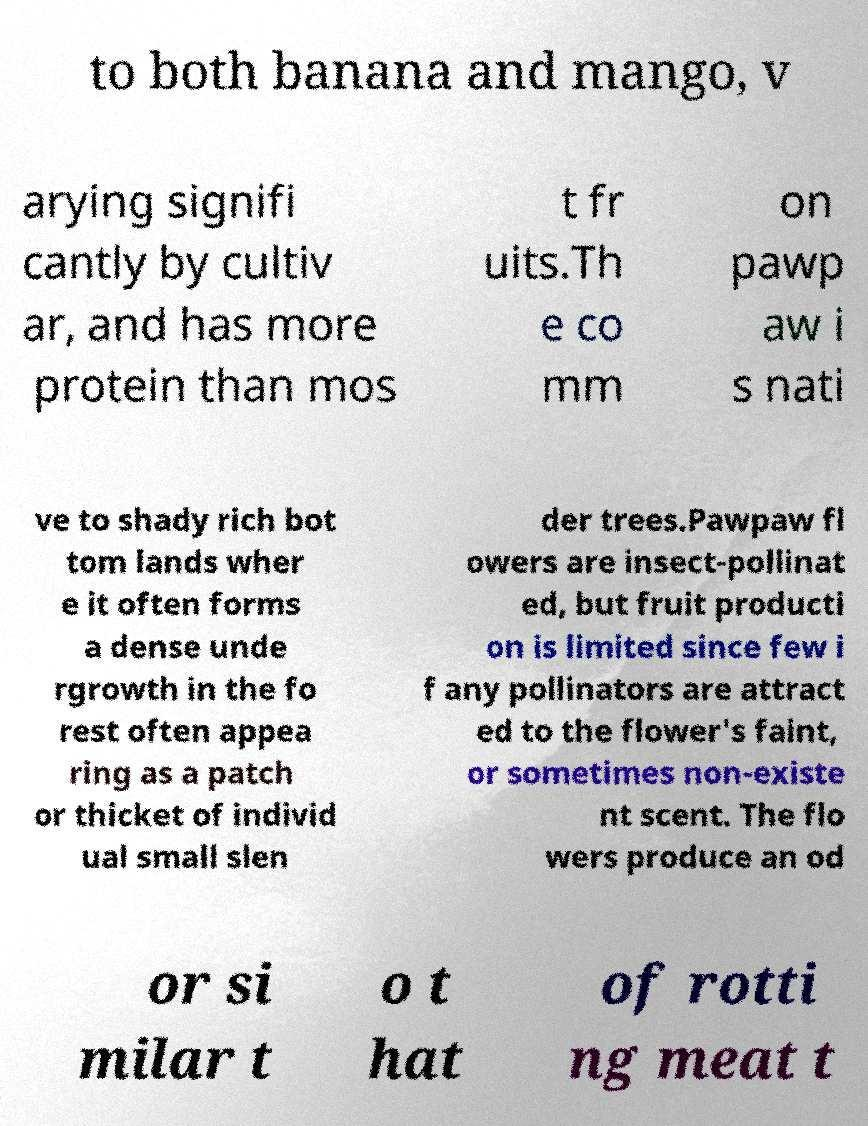Can you read and provide the text displayed in the image?This photo seems to have some interesting text. Can you extract and type it out for me? to both banana and mango, v arying signifi cantly by cultiv ar, and has more protein than mos t fr uits.Th e co mm on pawp aw i s nati ve to shady rich bot tom lands wher e it often forms a dense unde rgrowth in the fo rest often appea ring as a patch or thicket of individ ual small slen der trees.Pawpaw fl owers are insect-pollinat ed, but fruit producti on is limited since few i f any pollinators are attract ed to the flower's faint, or sometimes non-existe nt scent. The flo wers produce an od or si milar t o t hat of rotti ng meat t 